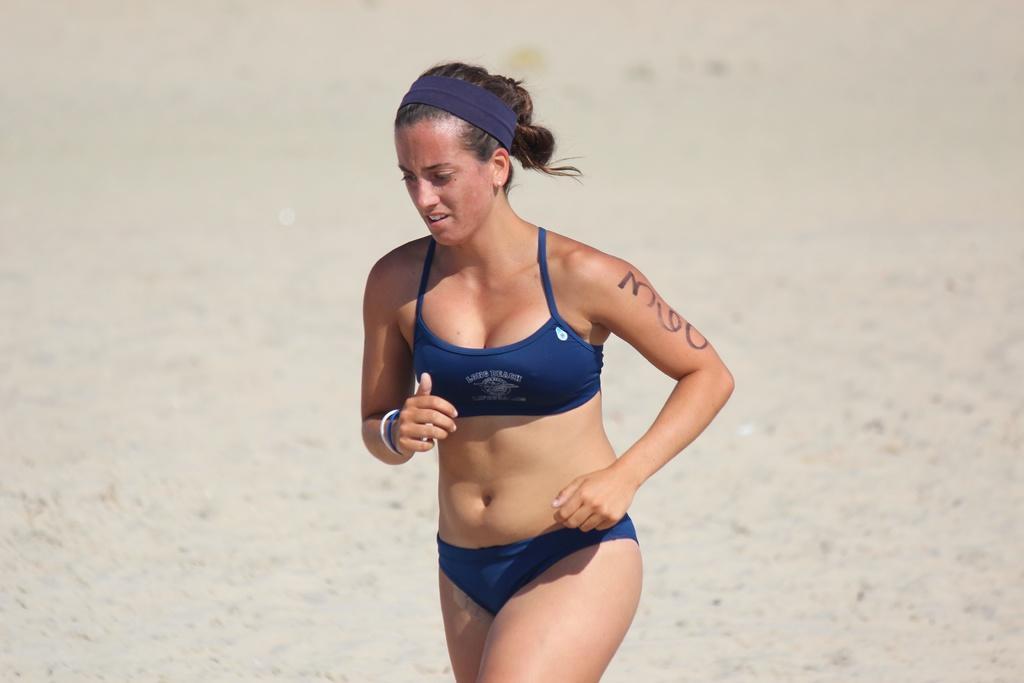In one or two sentences, can you explain what this image depicts? In the middle of the image we can see a woman and she is running. 